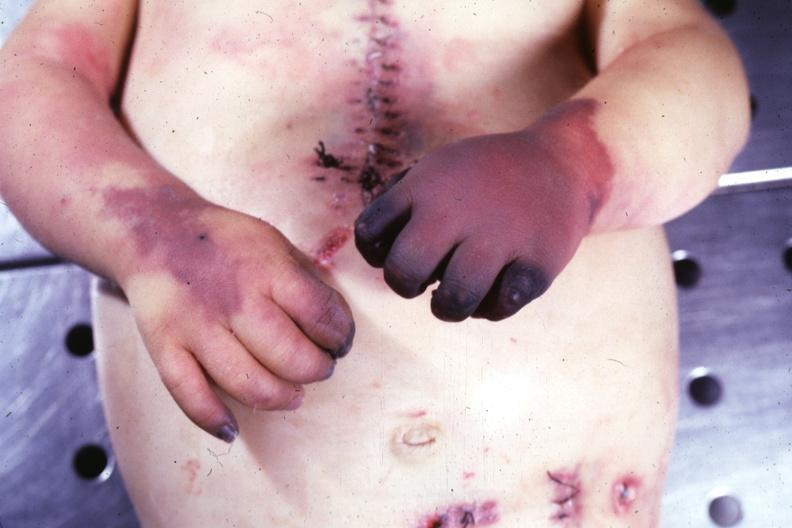does this image show gangrene both hands due to embolism case of av canal with downs syndrome?
Answer the question using a single word or phrase. Yes 